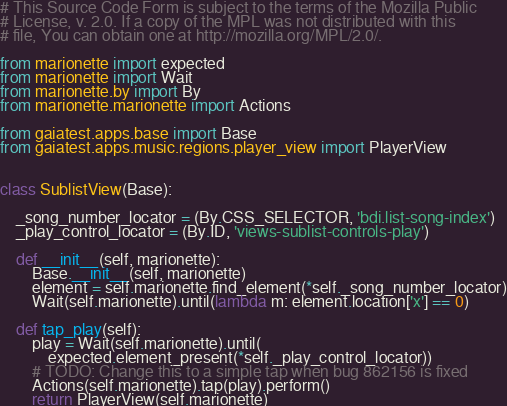<code> <loc_0><loc_0><loc_500><loc_500><_Python_># This Source Code Form is subject to the terms of the Mozilla Public
# License, v. 2.0. If a copy of the MPL was not distributed with this
# file, You can obtain one at http://mozilla.org/MPL/2.0/.

from marionette import expected
from marionette import Wait
from marionette.by import By
from marionette.marionette import Actions

from gaiatest.apps.base import Base
from gaiatest.apps.music.regions.player_view import PlayerView


class SublistView(Base):

    _song_number_locator = (By.CSS_SELECTOR, 'bdi.list-song-index')
    _play_control_locator = (By.ID, 'views-sublist-controls-play')

    def __init__(self, marionette):
        Base.__init__(self, marionette)
        element = self.marionette.find_element(*self._song_number_locator)
        Wait(self.marionette).until(lambda m: element.location['x'] == 0)

    def tap_play(self):
        play = Wait(self.marionette).until(
            expected.element_present(*self._play_control_locator))
        # TODO: Change this to a simple tap when bug 862156 is fixed
        Actions(self.marionette).tap(play).perform()
        return PlayerView(self.marionette)
</code> 